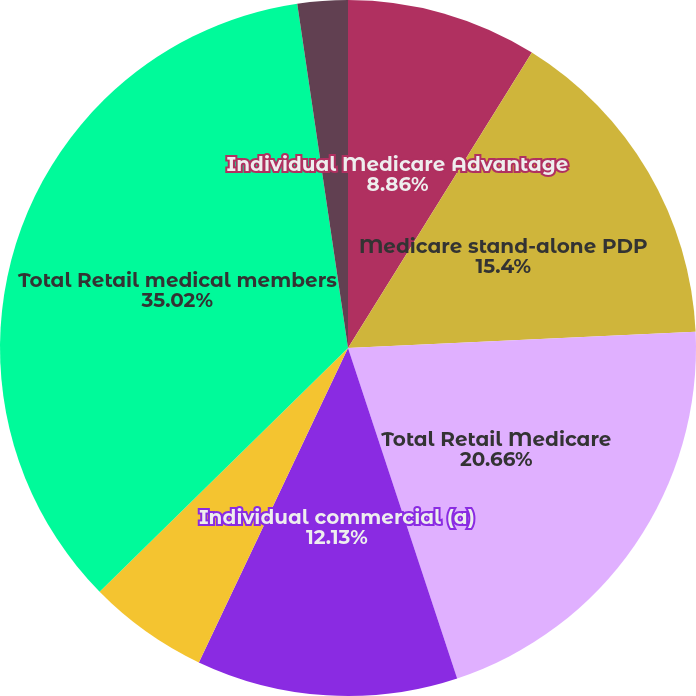Convert chart to OTSL. <chart><loc_0><loc_0><loc_500><loc_500><pie_chart><fcel>Individual Medicare Advantage<fcel>Medicare stand-alone PDP<fcel>Total Retail Medicare<fcel>Individual commercial (a)<fcel>State-based Medicaid<fcel>Total Retail medical members<fcel>Individual specialty<nl><fcel>8.86%<fcel>15.4%<fcel>20.66%<fcel>12.13%<fcel>5.6%<fcel>35.02%<fcel>2.33%<nl></chart> 